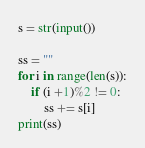Convert code to text. <code><loc_0><loc_0><loc_500><loc_500><_Python_>s = str(input())

ss = ""
for i in range(len(s)):
	if (i +1)%2 != 0:
		ss += s[i]
print(ss)</code> 